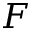Convert formula to latex. <formula><loc_0><loc_0><loc_500><loc_500>F</formula> 